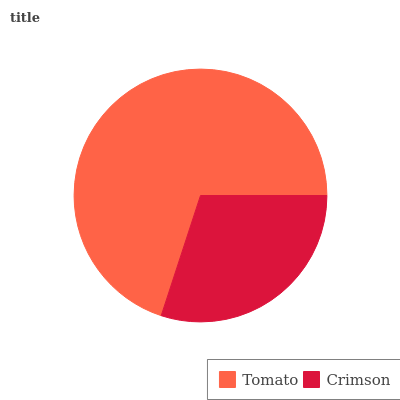Is Crimson the minimum?
Answer yes or no. Yes. Is Tomato the maximum?
Answer yes or no. Yes. Is Crimson the maximum?
Answer yes or no. No. Is Tomato greater than Crimson?
Answer yes or no. Yes. Is Crimson less than Tomato?
Answer yes or no. Yes. Is Crimson greater than Tomato?
Answer yes or no. No. Is Tomato less than Crimson?
Answer yes or no. No. Is Tomato the high median?
Answer yes or no. Yes. Is Crimson the low median?
Answer yes or no. Yes. Is Crimson the high median?
Answer yes or no. No. Is Tomato the low median?
Answer yes or no. No. 